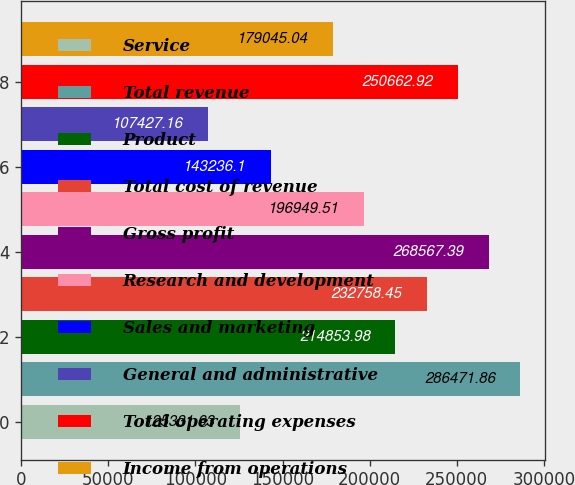Convert chart to OTSL. <chart><loc_0><loc_0><loc_500><loc_500><bar_chart><fcel>Service<fcel>Total revenue<fcel>Product<fcel>Total cost of revenue<fcel>Gross profit<fcel>Research and development<fcel>Sales and marketing<fcel>General and administrative<fcel>Total operating expenses<fcel>Income from operations<nl><fcel>125332<fcel>286472<fcel>214854<fcel>232758<fcel>268567<fcel>196950<fcel>143236<fcel>107427<fcel>250663<fcel>179045<nl></chart> 